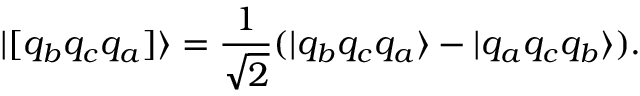Convert formula to latex. <formula><loc_0><loc_0><loc_500><loc_500>| [ q _ { b } q _ { c } q _ { a } ] \rangle = \frac { 1 } { \sqrt { 2 } } ( | q _ { b } q _ { c } q _ { a } \rangle - | q _ { a } q _ { c } q _ { b } \rangle ) .</formula> 